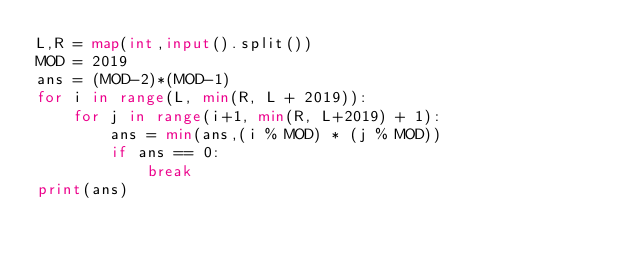<code> <loc_0><loc_0><loc_500><loc_500><_Python_>L,R = map(int,input().split())
MOD = 2019
ans = (MOD-2)*(MOD-1)
for i in range(L, min(R, L + 2019)):
    for j in range(i+1, min(R, L+2019) + 1):
        ans = min(ans,(i % MOD) * (j % MOD))
        if ans == 0:
            break
print(ans)</code> 